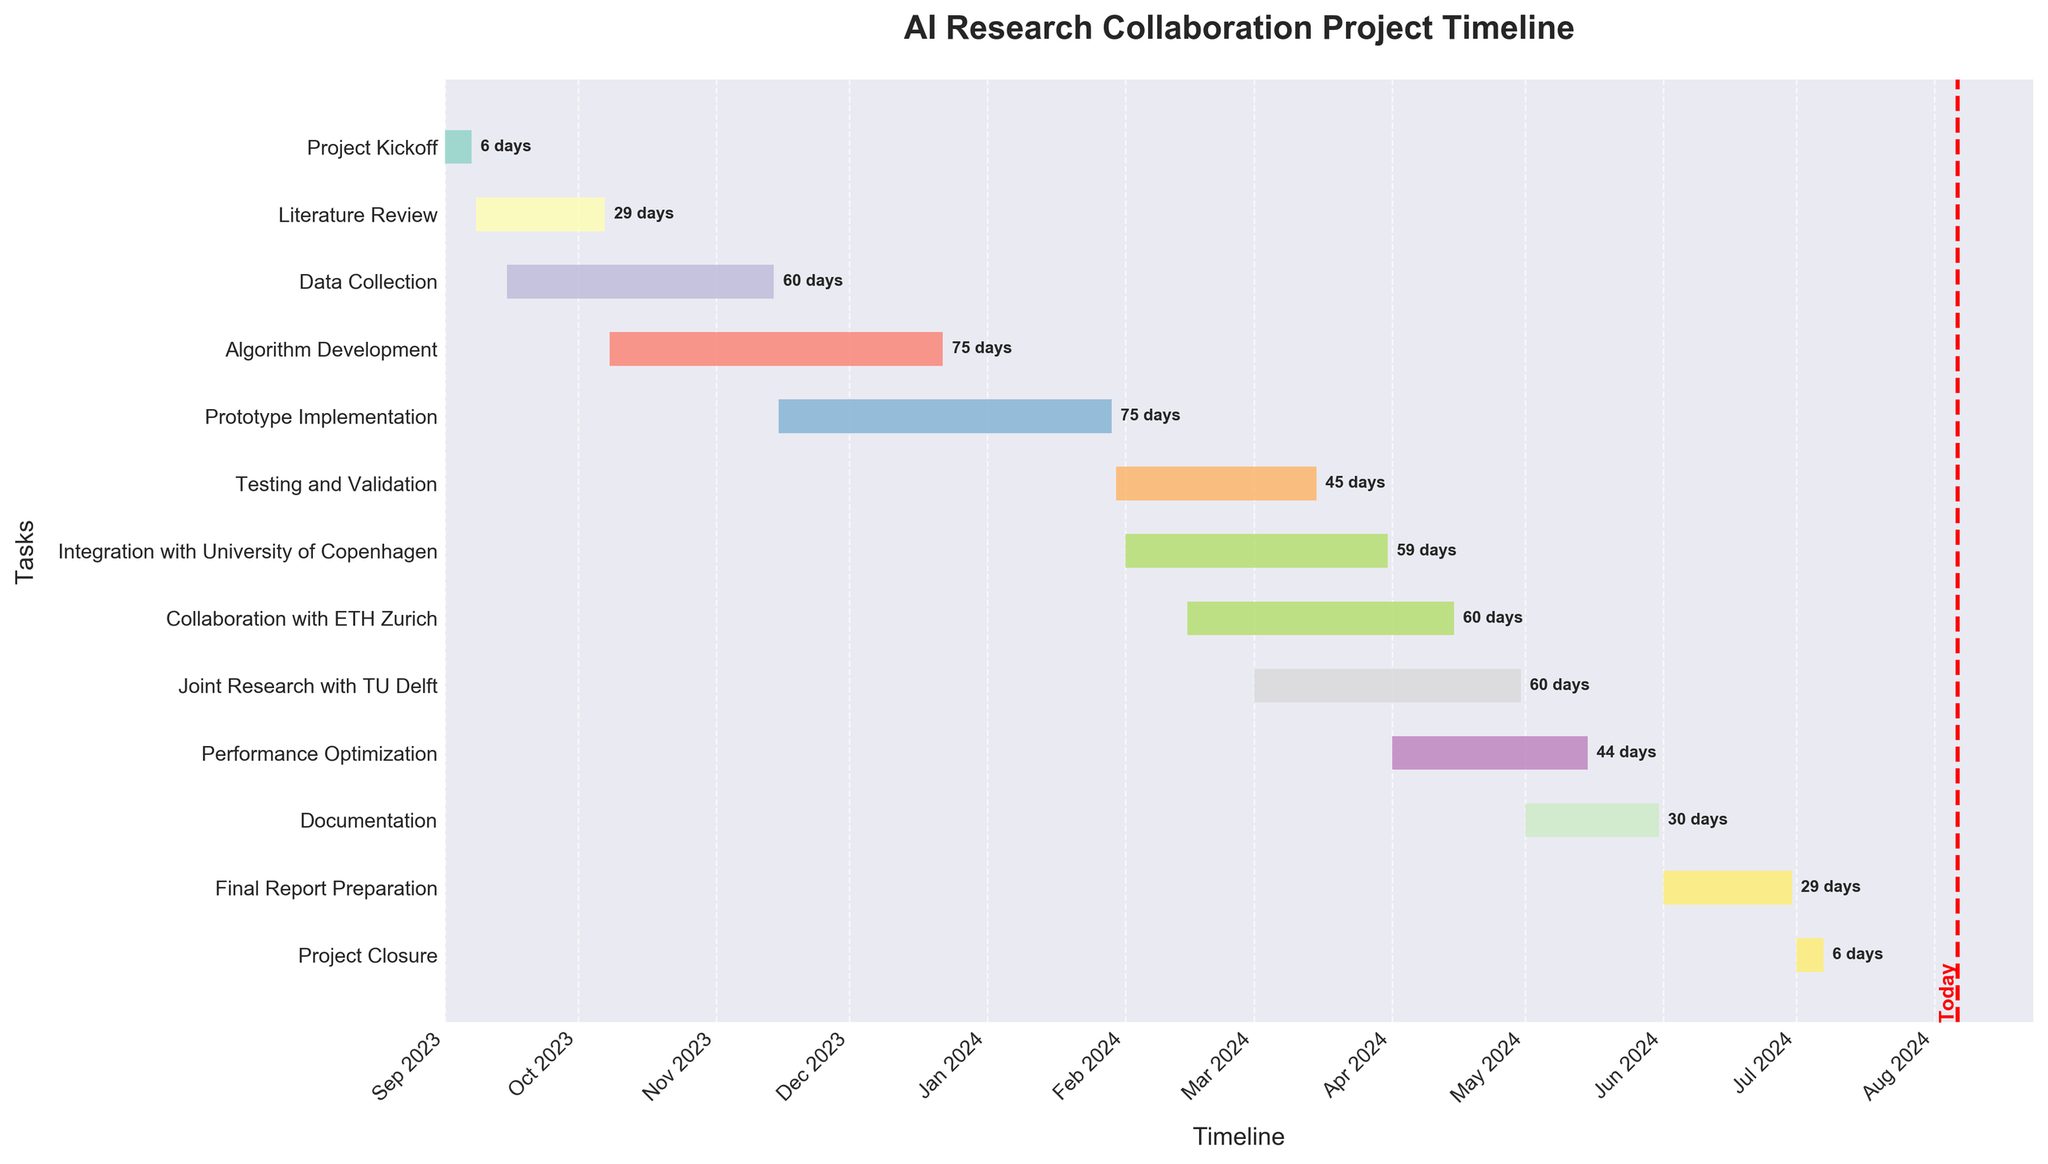What's the title of the figure? The title of the figure is located at the top and often is the largest text which helps to understand the main topic of the chart. By reading the title, we can identify it as "AI Research Collaboration Project Timeline".
Answer: AI Research Collaboration Project Timeline What are the start and end dates for the "Algorithm Development" task? The Gantt chart depicts the start and end dates directly on the horizontal axis through the length of the bar for the "Algorithm Development" task. The start date is 2023-10-08, and the end date is 2023-12-22.
Answer: 2023-10-08 to 2023-12-22 Which task has the shortest duration and what is its duration? The duration of each task is mentioned at the end of each bar in the Gantt chart. Reviewing them reveals that "Project Kickoff" and "Project Closure" each have the shortest duration of 7 days.
Answer: Project Kickoff and Project Closure, 7 days How long does "Literature Review" overlap with "Data Collection"? To determine overlap, compare the dates visually on the chart. "Literature Review" runs from 2023-09-08 to 2023-10-07, while "Data Collection" spans from 2023-09-15 to 2023-11-14. The overlap duration is from 2023-09-15 to 2023-10-07.
Answer: 23 days Which other tasks are ongoing when "Collaboration with ETH Zurich" starts? To find this, locate the start date of "Collaboration with ETH Zurich" (2024-02-15) and check which tasks are active at this point. At this time, "Testing and Validation", "Integration with University of Copenhagen", and "Prototype Implementation" are ongoing.
Answer: Testing and Validation, Integration with University of Copenhagen, Prototype Implementation How many tasks are scheduled to be active during March 2024? By analyzing the Gantt chart bars that cover the period during March 2024, we see that "Testing and Validation", "Integration with University of Copenhagen", "Collaboration with ETH Zurich", and "Joint Research with TU Delft" tasks overlap this period. Thus, four tasks will be active in March 2024.
Answer: 4 tasks What's the duration between the start of "Final Report Preparation" and the end of "Project Closure"? "Final Report Preparation" starts on 2024-06-01 and "Project Closure" ends on 2024-07-07. Calculate the duration from the start date of "Final Report Preparation" to the end date of "Project Closure". The duration is from 2024-06-01 to 2024-07-07.
Answer: 37 days Which task completes last in the project timeline, and on which date does it finish? By examining the end dates visually on the Gantt chart, it’s clear that the "Project Closure" task finishes last, with an end date of 2024-07-07.
Answer: Project Closure on 2024-07-07 During which months does "Performance Optimization" take place? The Gantt chart's bars indicate the duration visually. By observing the bar for "Performance Optimization", it spans from 2024-04-01 to 2024-05-15, which covers April and May of 2024.
Answer: April and May 2024 